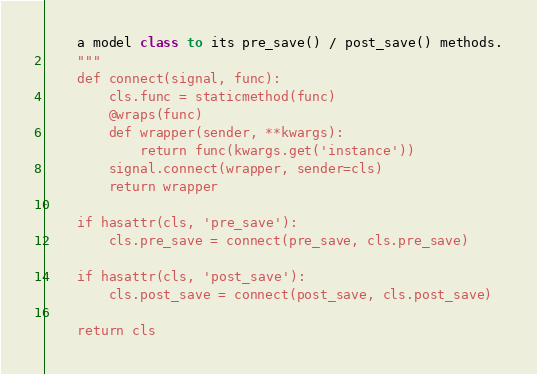<code> <loc_0><loc_0><loc_500><loc_500><_Python_>    a model class to its pre_save() / post_save() methods.
    """
    def connect(signal, func):
        cls.func = staticmethod(func)
        @wraps(func)
        def wrapper(sender, **kwargs):
            return func(kwargs.get('instance'))
        signal.connect(wrapper, sender=cls)
        return wrapper

    if hasattr(cls, 'pre_save'):
        cls.pre_save = connect(pre_save, cls.pre_save)

    if hasattr(cls, 'post_save'):
        cls.post_save = connect(post_save, cls.post_save)

    return cls
</code> 